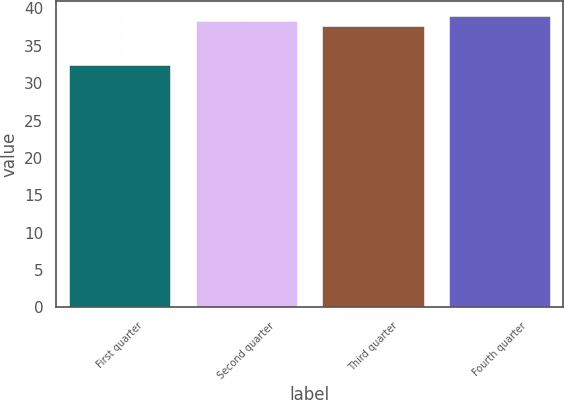Convert chart to OTSL. <chart><loc_0><loc_0><loc_500><loc_500><bar_chart><fcel>First quarter<fcel>Second quarter<fcel>Third quarter<fcel>Fourth quarter<nl><fcel>32.37<fcel>38.33<fcel>37.67<fcel>38.99<nl></chart> 